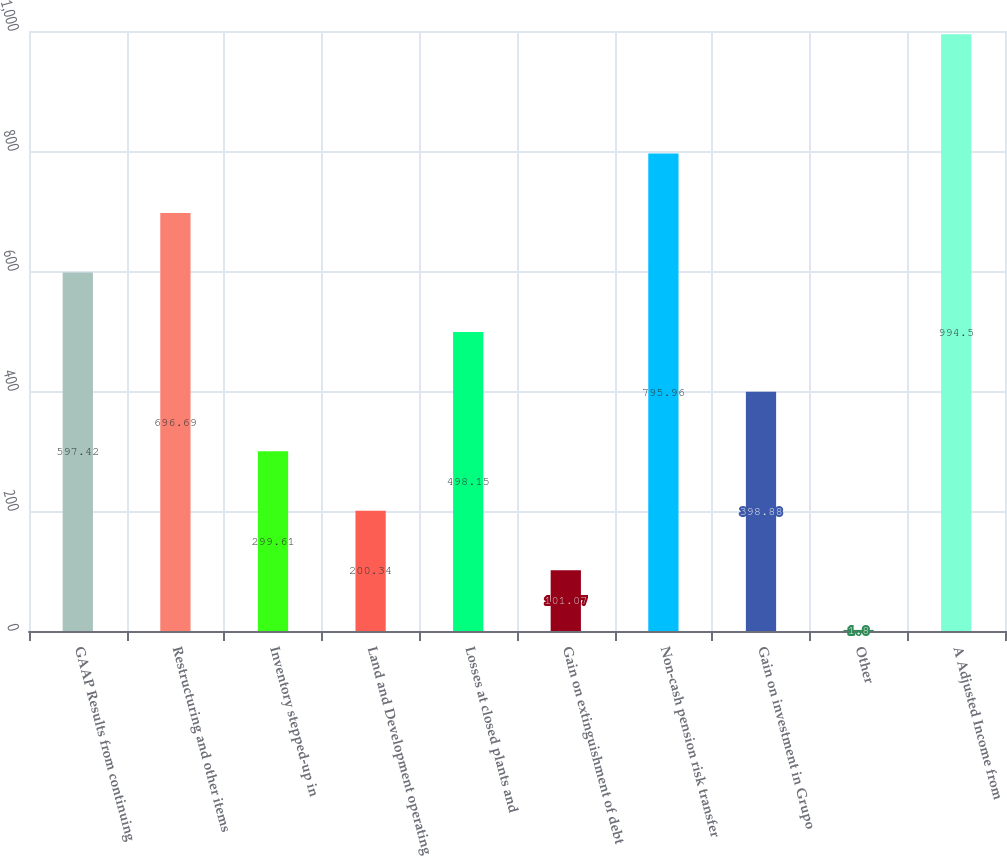<chart> <loc_0><loc_0><loc_500><loc_500><bar_chart><fcel>GAAP Results from continuing<fcel>Restructuring and other items<fcel>Inventory stepped-up in<fcel>Land and Development operating<fcel>Losses at closed plants and<fcel>Gain on extinguishment of debt<fcel>Non-cash pension risk transfer<fcel>Gain on investment in Grupo<fcel>Other<fcel>A Adjusted Income from<nl><fcel>597.42<fcel>696.69<fcel>299.61<fcel>200.34<fcel>498.15<fcel>101.07<fcel>795.96<fcel>398.88<fcel>1.8<fcel>994.5<nl></chart> 